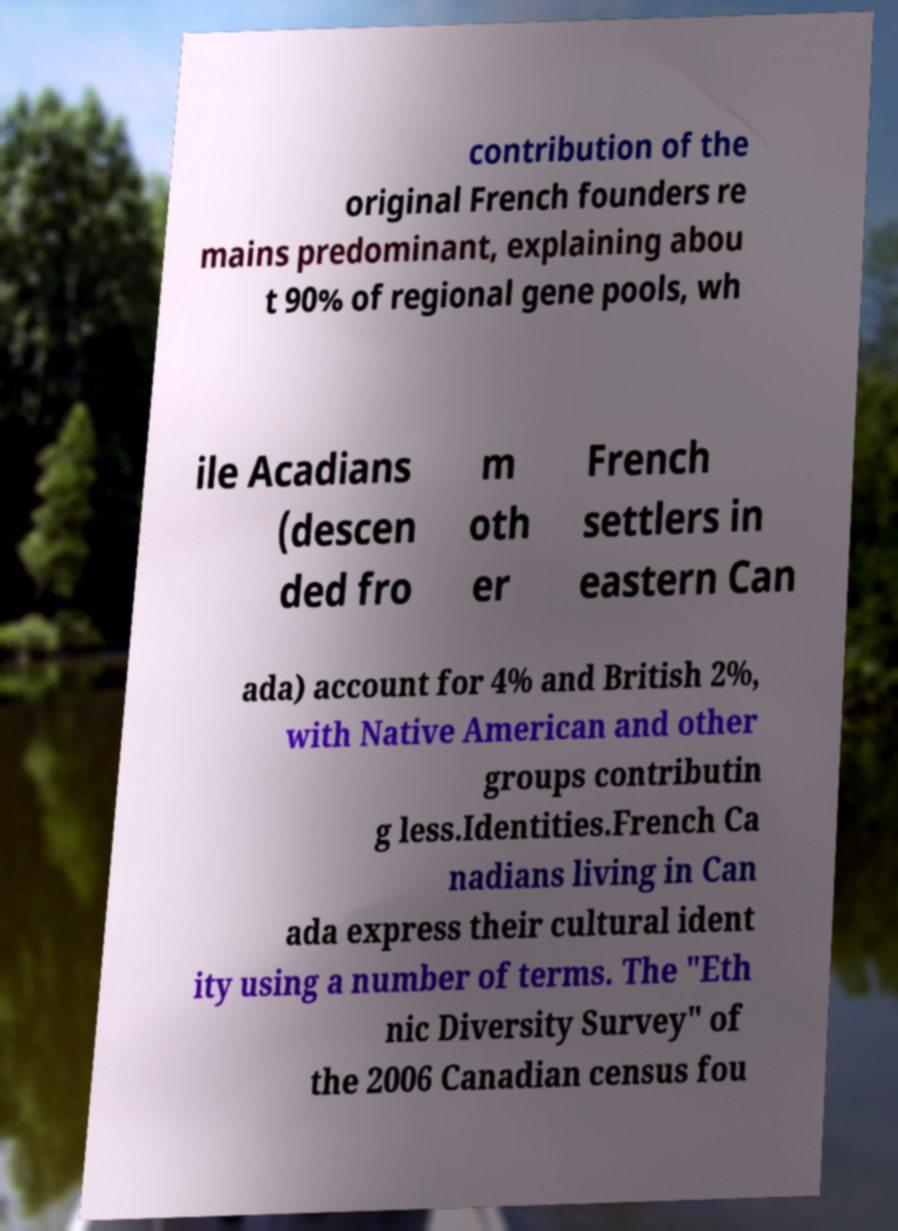Can you read and provide the text displayed in the image?This photo seems to have some interesting text. Can you extract and type it out for me? contribution of the original French founders re mains predominant, explaining abou t 90% of regional gene pools, wh ile Acadians (descen ded fro m oth er French settlers in eastern Can ada) account for 4% and British 2%, with Native American and other groups contributin g less.Identities.French Ca nadians living in Can ada express their cultural ident ity using a number of terms. The "Eth nic Diversity Survey" of the 2006 Canadian census fou 